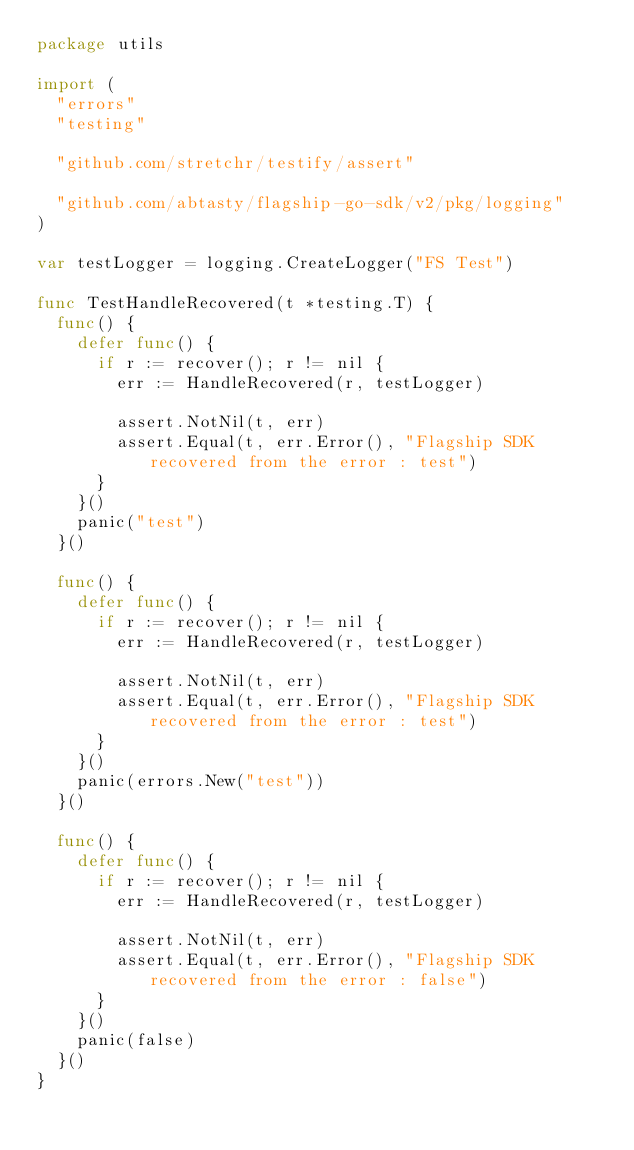<code> <loc_0><loc_0><loc_500><loc_500><_Go_>package utils

import (
	"errors"
	"testing"

	"github.com/stretchr/testify/assert"

	"github.com/abtasty/flagship-go-sdk/v2/pkg/logging"
)

var testLogger = logging.CreateLogger("FS Test")

func TestHandleRecovered(t *testing.T) {
	func() {
		defer func() {
			if r := recover(); r != nil {
				err := HandleRecovered(r, testLogger)

				assert.NotNil(t, err)
				assert.Equal(t, err.Error(), "Flagship SDK recovered from the error : test")
			}
		}()
		panic("test")
	}()

	func() {
		defer func() {
			if r := recover(); r != nil {
				err := HandleRecovered(r, testLogger)

				assert.NotNil(t, err)
				assert.Equal(t, err.Error(), "Flagship SDK recovered from the error : test")
			}
		}()
		panic(errors.New("test"))
	}()

	func() {
		defer func() {
			if r := recover(); r != nil {
				err := HandleRecovered(r, testLogger)

				assert.NotNil(t, err)
				assert.Equal(t, err.Error(), "Flagship SDK recovered from the error : false")
			}
		}()
		panic(false)
	}()
}
</code> 